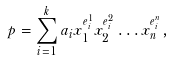<formula> <loc_0><loc_0><loc_500><loc_500>p = \sum _ { i = 1 } ^ { k } a _ { i } x _ { 1 } ^ { e ^ { 1 } _ { i } } x _ { 2 } ^ { e ^ { 2 } _ { i } } \hdots x _ { n } ^ { e ^ { n } _ { i } } ,</formula> 